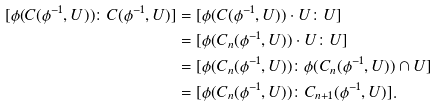Convert formula to latex. <formula><loc_0><loc_0><loc_500><loc_500>[ \phi ( C ( \phi ^ { - 1 } , U ) ) \colon C ( \phi ^ { - 1 } , U ) ] & = [ \phi ( C ( \phi ^ { - 1 } , U ) ) \cdot U \colon U ] \\ & = [ \phi ( C _ { n } ( \phi ^ { - 1 } , U ) ) \cdot U \colon U ] \\ & = [ \phi ( C _ { n } ( \phi ^ { - 1 } , U ) ) \colon \phi ( C _ { n } ( \phi ^ { - 1 } , U ) ) \cap U ] \\ & = [ \phi ( C _ { n } ( \phi ^ { - 1 } , U ) ) \colon C _ { n + 1 } ( \phi ^ { - 1 } , U ) ] .</formula> 